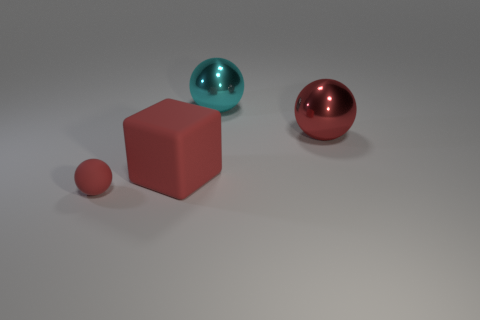Subtract all matte spheres. How many spheres are left? 2 Add 3 gray metal cylinders. How many objects exist? 7 Subtract all yellow cubes. How many red spheres are left? 2 Subtract 1 spheres. How many spheres are left? 2 Subtract all cyan spheres. How many spheres are left? 2 Subtract all blocks. How many objects are left? 3 Subtract 0 yellow balls. How many objects are left? 4 Subtract all yellow blocks. Subtract all yellow balls. How many blocks are left? 1 Subtract all large yellow cylinders. Subtract all large cubes. How many objects are left? 3 Add 1 red rubber blocks. How many red rubber blocks are left? 2 